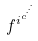Convert formula to latex. <formula><loc_0><loc_0><loc_500><loc_500>f ^ { i ^ { c ^ { \cdot ^ { \cdot ^ { \cdot } } } } }</formula> 